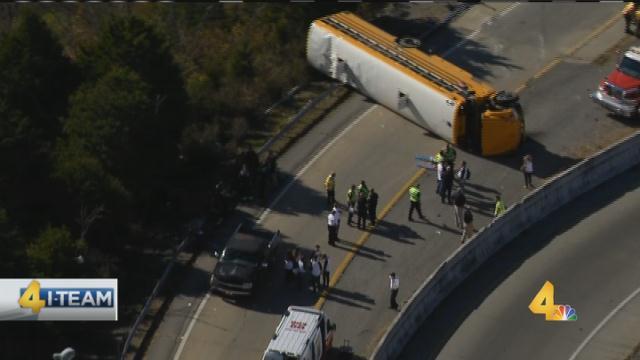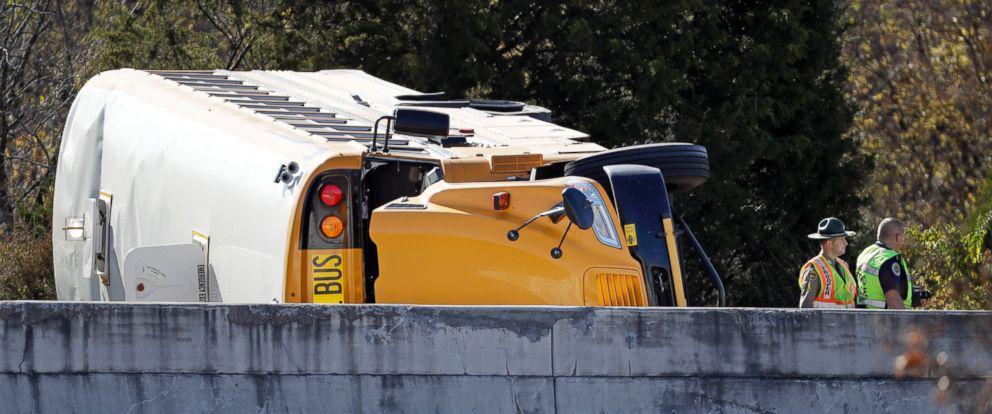The first image is the image on the left, the second image is the image on the right. Assess this claim about the two images: "The right image contains a school bus that is flipped onto its side.". Correct or not? Answer yes or no. Yes. 